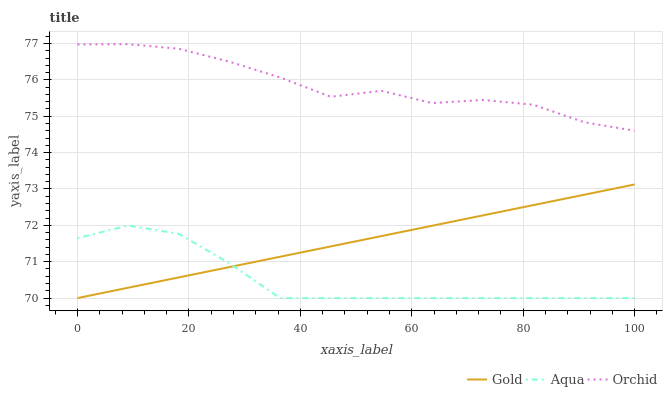Does Aqua have the minimum area under the curve?
Answer yes or no. Yes. Does Orchid have the maximum area under the curve?
Answer yes or no. Yes. Does Gold have the minimum area under the curve?
Answer yes or no. No. Does Gold have the maximum area under the curve?
Answer yes or no. No. Is Gold the smoothest?
Answer yes or no. Yes. Is Orchid the roughest?
Answer yes or no. Yes. Is Orchid the smoothest?
Answer yes or no. No. Is Gold the roughest?
Answer yes or no. No. Does Orchid have the lowest value?
Answer yes or no. No. Does Orchid have the highest value?
Answer yes or no. Yes. Does Gold have the highest value?
Answer yes or no. No. Is Gold less than Orchid?
Answer yes or no. Yes. Is Orchid greater than Gold?
Answer yes or no. Yes. Does Aqua intersect Gold?
Answer yes or no. Yes. Is Aqua less than Gold?
Answer yes or no. No. Is Aqua greater than Gold?
Answer yes or no. No. Does Gold intersect Orchid?
Answer yes or no. No. 